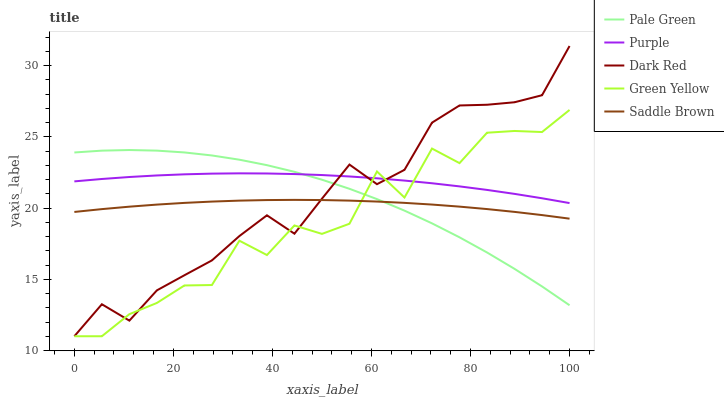Does Green Yellow have the minimum area under the curve?
Answer yes or no. Yes. Does Purple have the maximum area under the curve?
Answer yes or no. Yes. Does Dark Red have the minimum area under the curve?
Answer yes or no. No. Does Dark Red have the maximum area under the curve?
Answer yes or no. No. Is Saddle Brown the smoothest?
Answer yes or no. Yes. Is Green Yellow the roughest?
Answer yes or no. Yes. Is Dark Red the smoothest?
Answer yes or no. No. Is Dark Red the roughest?
Answer yes or no. No. Does Dark Red have the lowest value?
Answer yes or no. Yes. Does Pale Green have the lowest value?
Answer yes or no. No. Does Dark Red have the highest value?
Answer yes or no. Yes. Does Green Yellow have the highest value?
Answer yes or no. No. Is Saddle Brown less than Purple?
Answer yes or no. Yes. Is Purple greater than Saddle Brown?
Answer yes or no. Yes. Does Purple intersect Green Yellow?
Answer yes or no. Yes. Is Purple less than Green Yellow?
Answer yes or no. No. Is Purple greater than Green Yellow?
Answer yes or no. No. Does Saddle Brown intersect Purple?
Answer yes or no. No. 